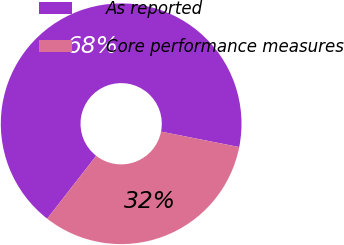Convert chart. <chart><loc_0><loc_0><loc_500><loc_500><pie_chart><fcel>As reported<fcel>Core performance measures<nl><fcel>67.57%<fcel>32.43%<nl></chart> 